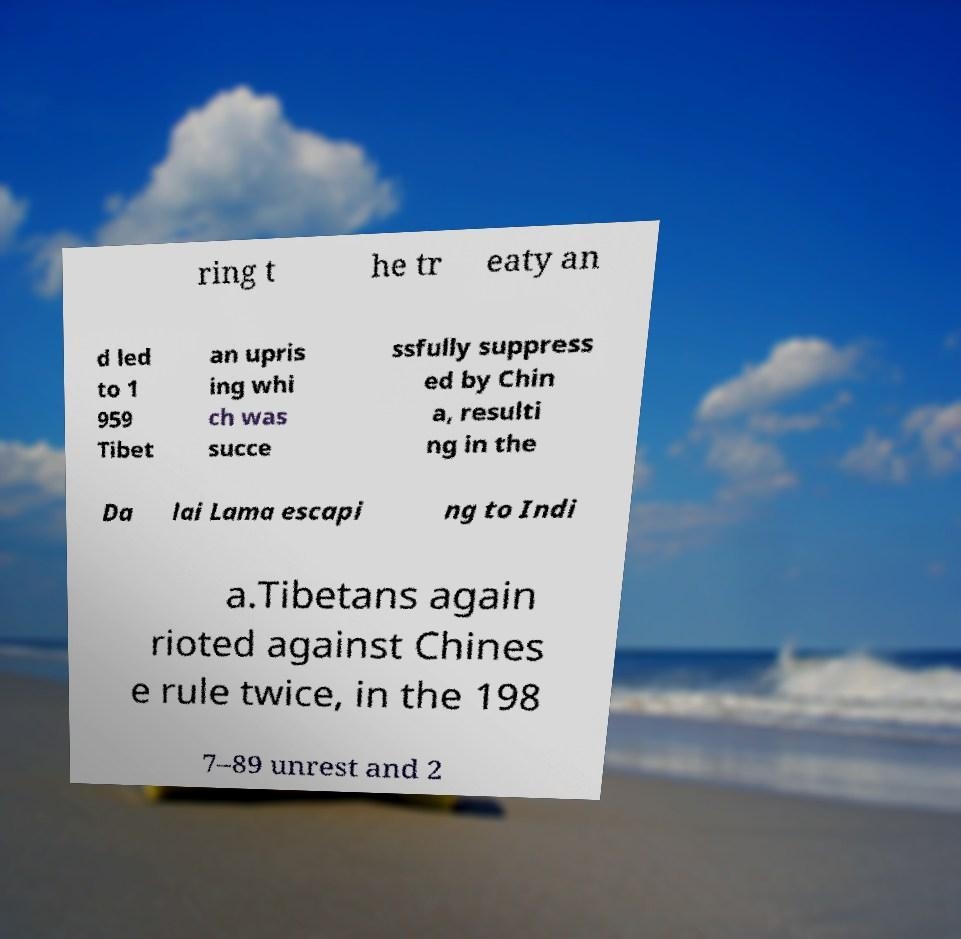Could you assist in decoding the text presented in this image and type it out clearly? ring t he tr eaty an d led to 1 959 Tibet an upris ing whi ch was succe ssfully suppress ed by Chin a, resulti ng in the Da lai Lama escapi ng to Indi a.Tibetans again rioted against Chines e rule twice, in the 198 7–89 unrest and 2 